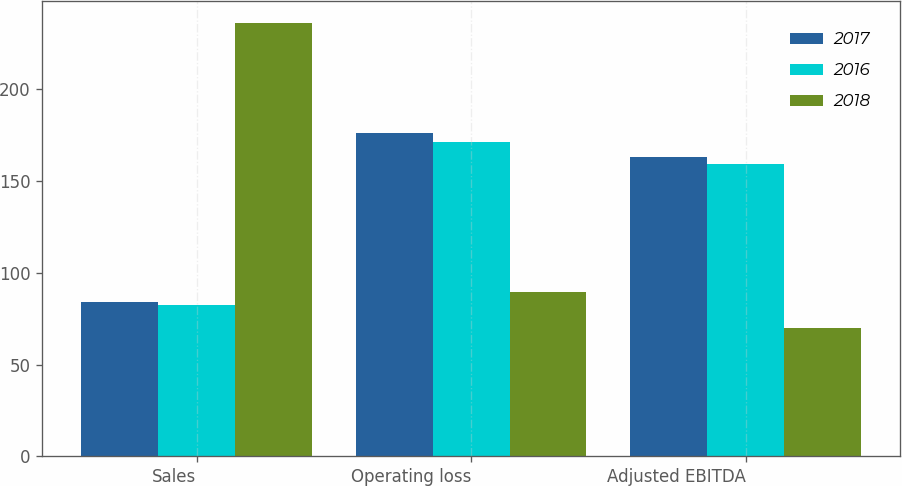Convert chart. <chart><loc_0><loc_0><loc_500><loc_500><stacked_bar_chart><ecel><fcel>Sales<fcel>Operating loss<fcel>Adjusted EBITDA<nl><fcel>2017<fcel>84<fcel>176<fcel>163.1<nl><fcel>2016<fcel>82.6<fcel>171.5<fcel>159.3<nl><fcel>2018<fcel>236<fcel>89.4<fcel>69.9<nl></chart> 